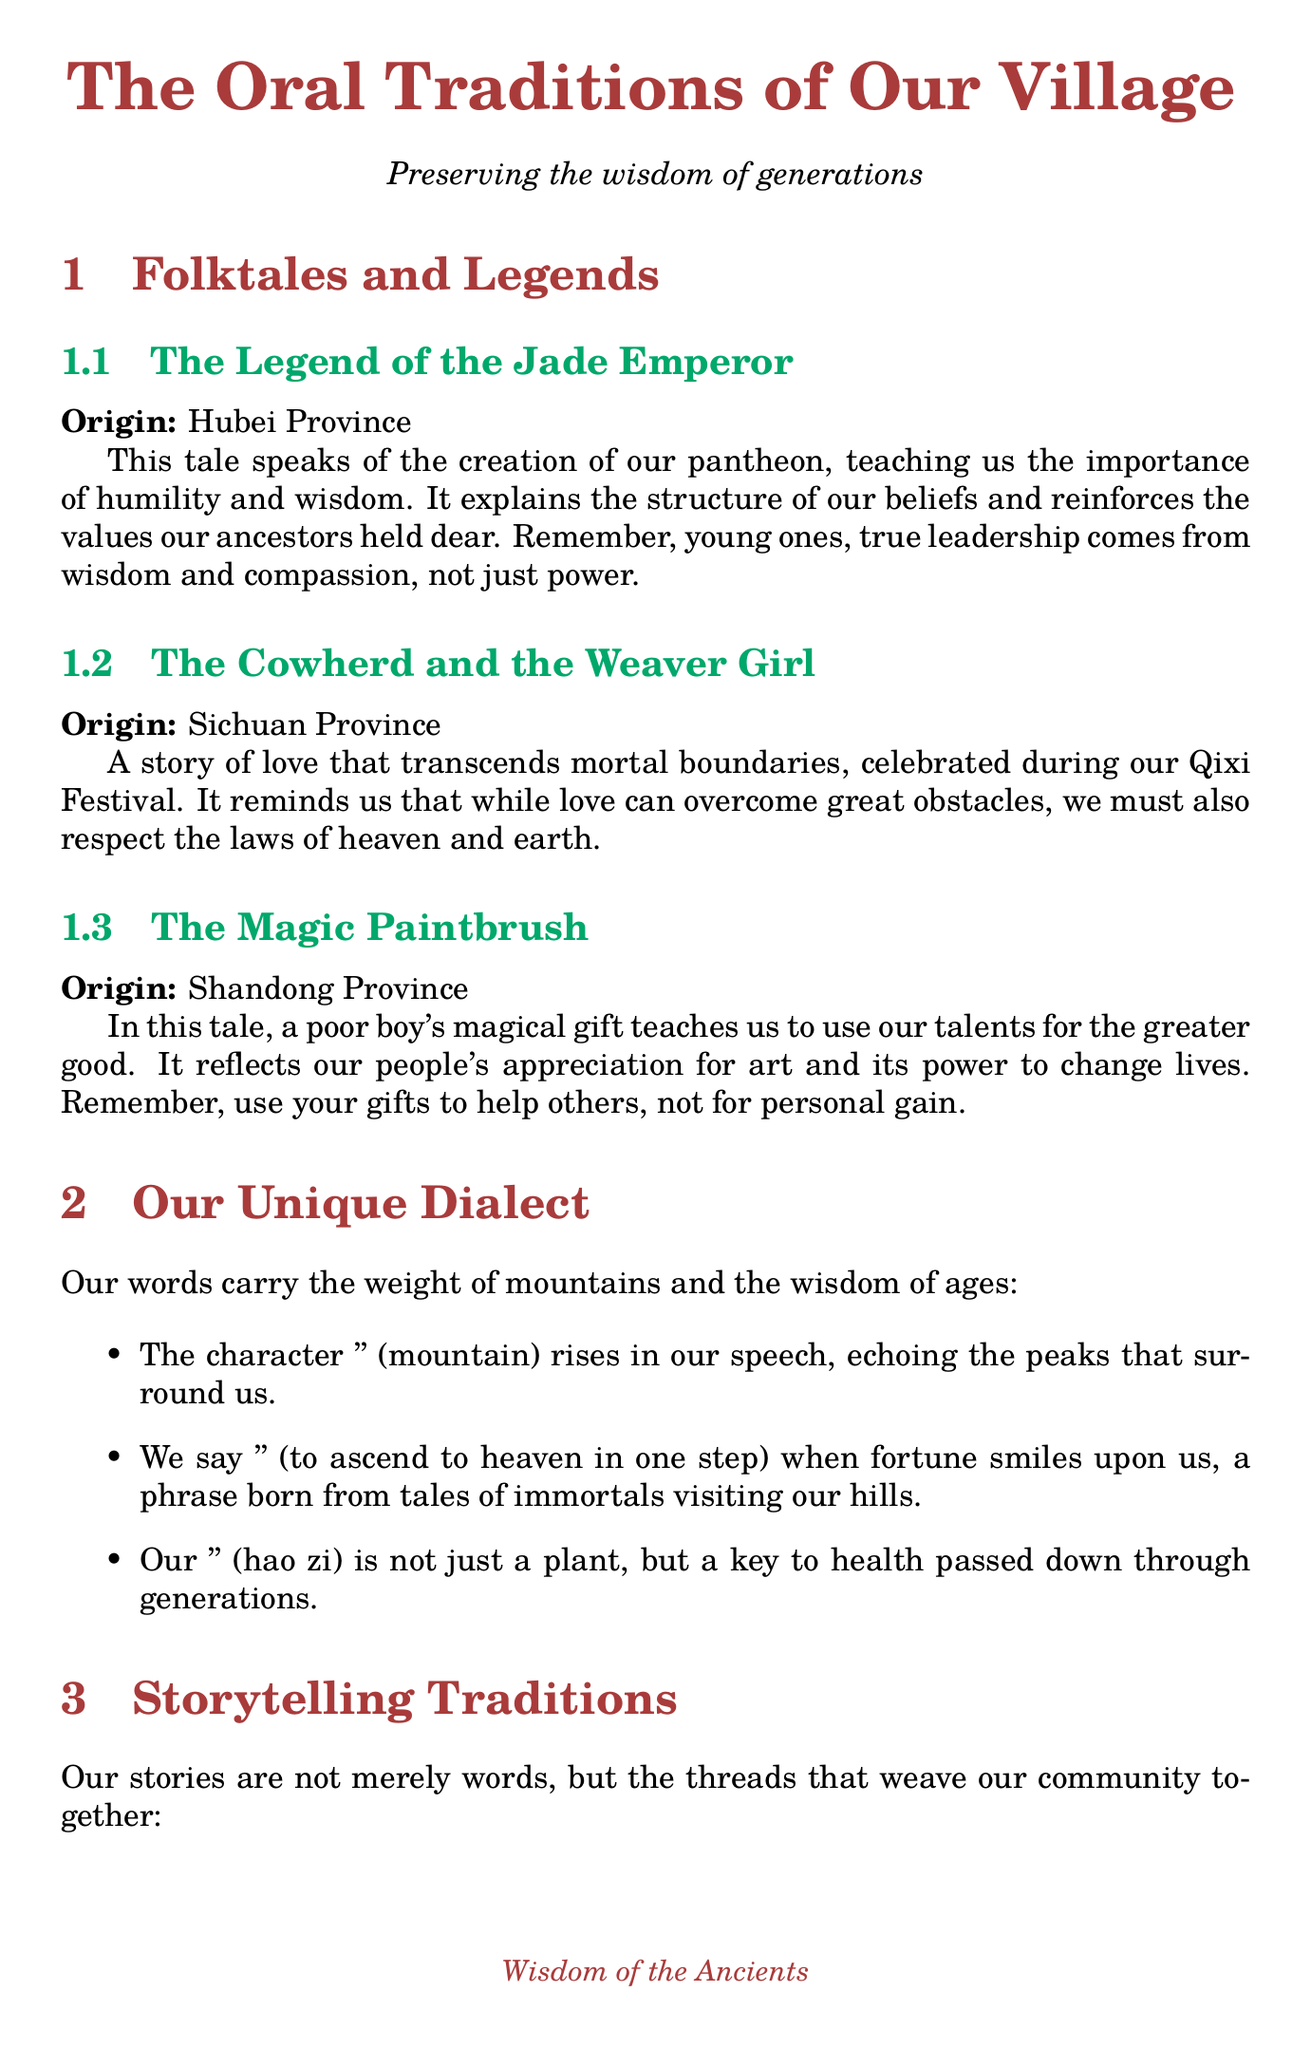What is the title of the first folktale? The first folktale is titled "The Legend of the Jade Emperor."
Answer: The Legend of the Jade Emperor Which province is the origin of "The Cowherd and the Weaver Girl"? The Cowherd and the Weaver Girl originates from Sichuan Province.
Answer: Sichuan Province What is the moral teaching of "The Magic Paintbrush"? The moral teaching of The Magic Paintbrush emphasizes using talents to aid others rather than for selfish reasons.
Answer: Use your talents to help others, not for personal gain or greed What unique element is associated with the character '山'? The unique element associated with '山' is its rising tone pronunciation.
Answer: Rising tone pronunciation How are stories told during the Moon Festival? Stories are told under the full moon, focusing on tales of Chang'e and the Jade Rabbit.
Answer: Under the full moon What initiative involves collaboration with Wuhan University? The initiative that involves collaboration with Wuhan University is the dialect recording project.
Answer: Dialect recording project What does the idiom '一步登天' translate to? The idiom '一步登天' translates to "to ascend to heaven in one step."
Answer: To ascend to heaven in one step How many storytelling traditions are mentioned in the document? The document mentions three storytelling traditions.
Answer: Three What does the village storytelling festival encourage? The village storytelling festival encourages intergenerational transmission of oral traditions.
Answer: Intergenerational transmission of oral traditions 